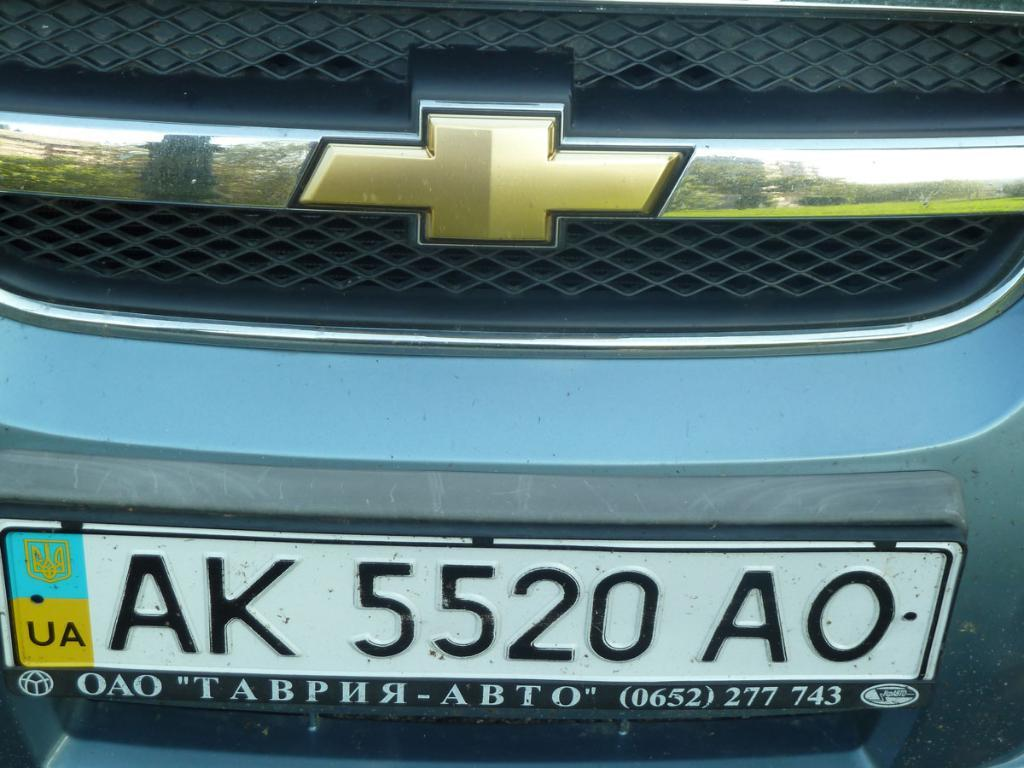<image>
Summarize the visual content of the image. UA logo with a AK 5520 AO license tag in the front. 